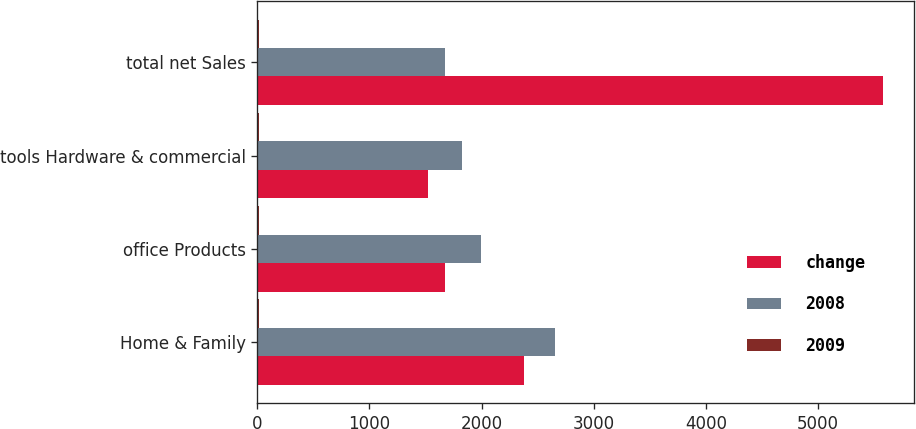<chart> <loc_0><loc_0><loc_500><loc_500><stacked_bar_chart><ecel><fcel>Home & Family<fcel>office Products<fcel>tools Hardware & commercial<fcel>total net Sales<nl><fcel>change<fcel>2377.2<fcel>1674.7<fcel>1525.7<fcel>5577.6<nl><fcel>2008<fcel>2654.8<fcel>1990.8<fcel>1825<fcel>1674.7<nl><fcel>2009<fcel>10.5<fcel>15.9<fcel>16.4<fcel>13.8<nl></chart> 